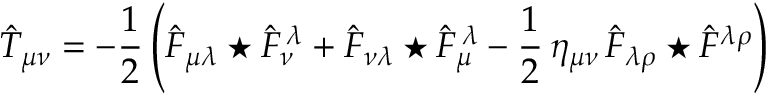<formula> <loc_0><loc_0><loc_500><loc_500>\hat { T } _ { \mu \nu } = - \frac { 1 } { 2 } \left ( \hat { F } _ { \mu \lambda } ^ { * } \hat { F } _ { \nu } ^ { \, \lambda } + \hat { F } _ { \nu \lambda } ^ { * } \hat { F } _ { \mu } ^ { \, \lambda } - \frac { 1 } { 2 } \, \eta _ { \mu \nu } \, \hat { F } _ { \lambda \rho } ^ { * } \hat { F } ^ { \lambda \rho } \right )</formula> 